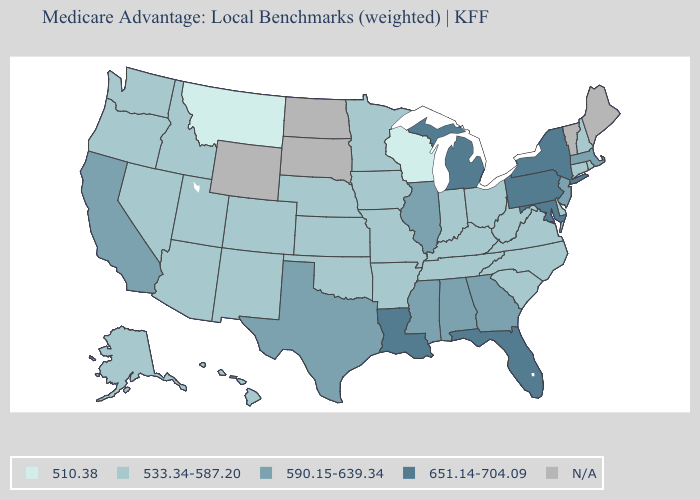Among the states that border Wyoming , does Montana have the highest value?
Concise answer only. No. Does Iowa have the lowest value in the USA?
Answer briefly. No. What is the value of South Carolina?
Write a very short answer. 533.34-587.20. What is the value of Nevada?
Answer briefly. 533.34-587.20. Which states have the highest value in the USA?
Short answer required. Florida, Louisiana, Maryland, Michigan, New York, Pennsylvania. What is the value of North Dakota?
Write a very short answer. N/A. What is the value of Georgia?
Answer briefly. 590.15-639.34. What is the value of Michigan?
Short answer required. 651.14-704.09. Does the first symbol in the legend represent the smallest category?
Quick response, please. Yes. Does the first symbol in the legend represent the smallest category?
Concise answer only. Yes. Name the states that have a value in the range 533.34-587.20?
Keep it brief. Alaska, Arkansas, Arizona, Colorado, Connecticut, Delaware, Hawaii, Iowa, Idaho, Indiana, Kansas, Kentucky, Minnesota, Missouri, North Carolina, Nebraska, New Hampshire, New Mexico, Nevada, Ohio, Oklahoma, Oregon, Rhode Island, South Carolina, Tennessee, Utah, Virginia, Washington, West Virginia. What is the value of Nebraska?
Write a very short answer. 533.34-587.20. What is the lowest value in the USA?
Short answer required. 510.38. 